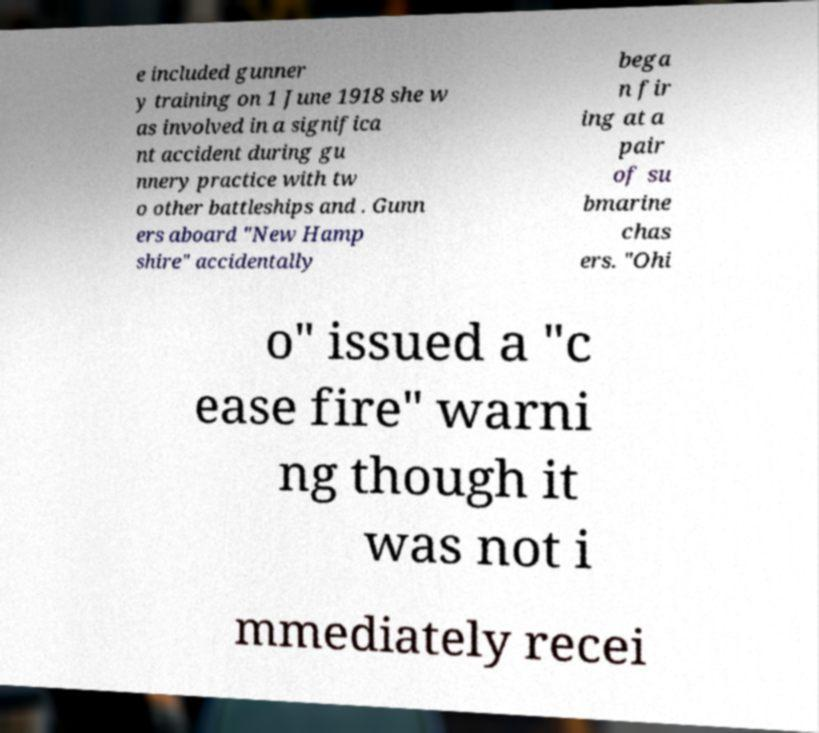Can you accurately transcribe the text from the provided image for me? e included gunner y training on 1 June 1918 she w as involved in a significa nt accident during gu nnery practice with tw o other battleships and . Gunn ers aboard "New Hamp shire" accidentally bega n fir ing at a pair of su bmarine chas ers. "Ohi o" issued a "c ease fire" warni ng though it was not i mmediately recei 